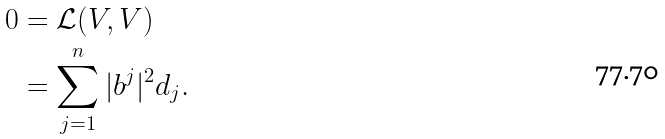<formula> <loc_0><loc_0><loc_500><loc_500>0 & = \mathcal { L } ( V , V ) \\ & = \sum _ { j = 1 } ^ { n } | b ^ { j } | ^ { 2 } d _ { j } .</formula> 